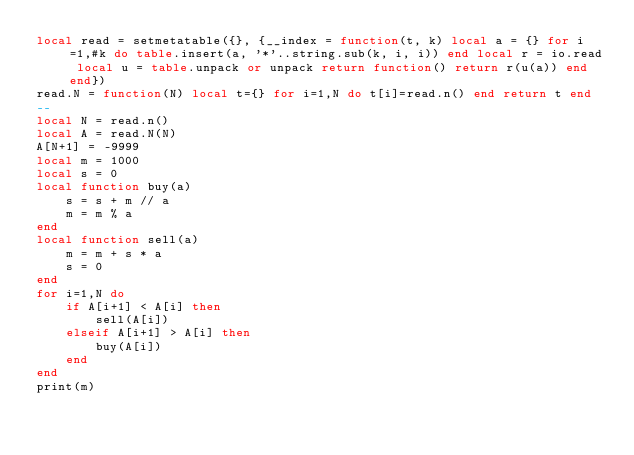<code> <loc_0><loc_0><loc_500><loc_500><_Lua_>local read = setmetatable({}, {__index = function(t, k) local a = {} for i=1,#k do table.insert(a, '*'..string.sub(k, i, i)) end local r = io.read local u = table.unpack or unpack return function() return r(u(a)) end end})
read.N = function(N) local t={} for i=1,N do t[i]=read.n() end return t end
--
local N = read.n()
local A = read.N(N)
A[N+1] = -9999
local m = 1000
local s = 0
local function buy(a)
    s = s + m // a
    m = m % a
end
local function sell(a)
    m = m + s * a
    s = 0
end
for i=1,N do
    if A[i+1] < A[i] then
        sell(A[i])
    elseif A[i+1] > A[i] then
        buy(A[i])
    end
end
print(m)</code> 